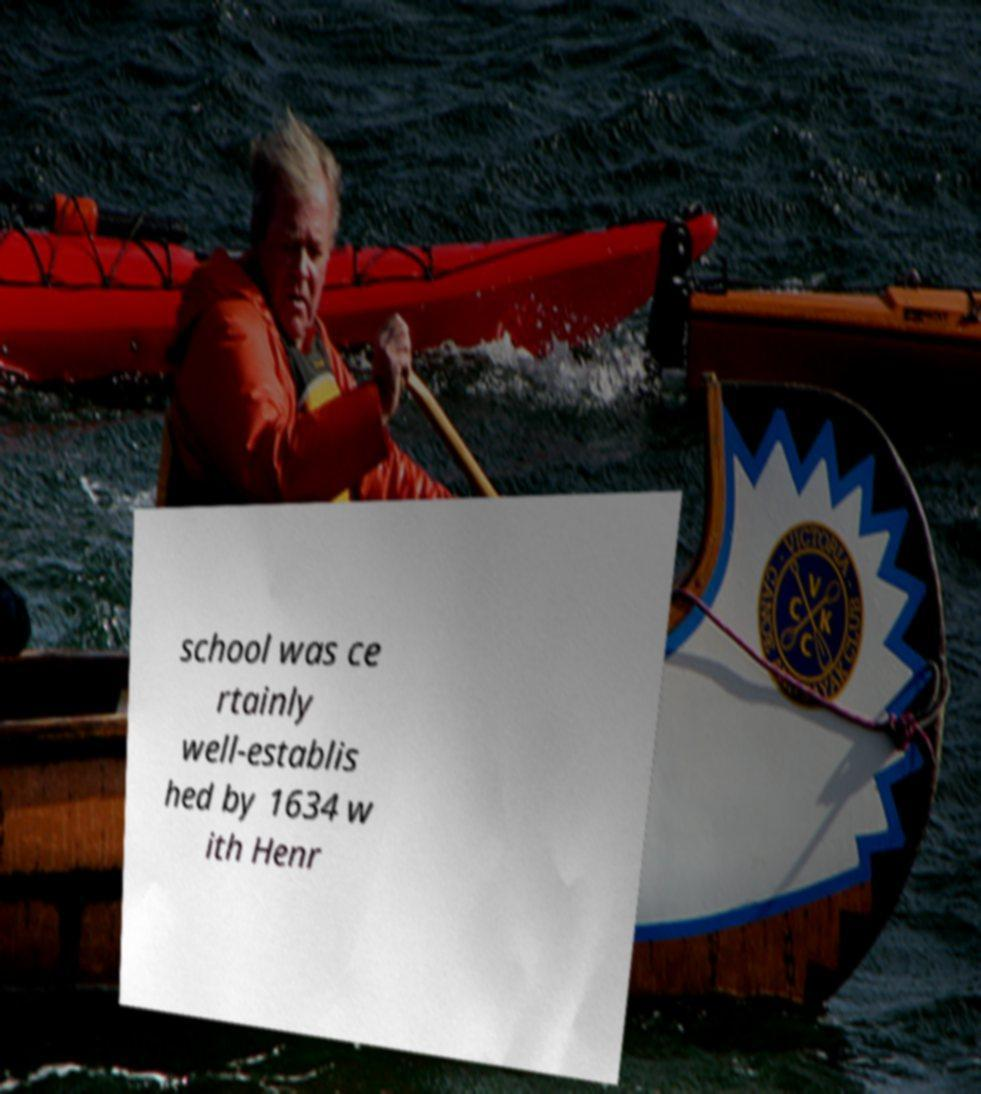Please read and relay the text visible in this image. What does it say? school was ce rtainly well-establis hed by 1634 w ith Henr 